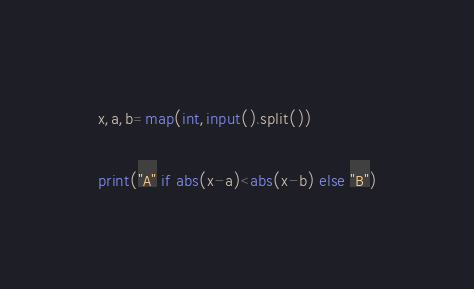Convert code to text. <code><loc_0><loc_0><loc_500><loc_500><_Python_>x,a,b=map(int,input().split())

print("A" if abs(x-a)<abs(x-b) else "B")</code> 